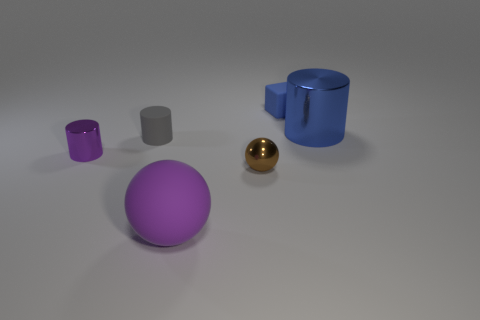The tiny matte cube has what color?
Keep it short and to the point. Blue. How many objects are large blue cylinders or large gray matte cylinders?
Your answer should be very brief. 1. There is a matte object that is behind the large object that is behind the purple rubber object; what is its shape?
Make the answer very short. Cube. How many other objects are the same material as the gray object?
Make the answer very short. 2. Are the blue block and the large thing that is on the right side of the block made of the same material?
Your answer should be compact. No. What number of objects are either shiny cylinders on the right side of the large matte thing or tiny objects in front of the tiny purple cylinder?
Offer a very short reply. 2. How many other objects are there of the same color as the large matte object?
Keep it short and to the point. 1. Is the number of gray things in front of the gray cylinder greater than the number of brown metallic objects that are behind the purple cylinder?
Provide a short and direct response. No. Is there anything else that has the same size as the purple matte thing?
Offer a very short reply. Yes. How many cylinders are large red rubber things or blue rubber things?
Offer a very short reply. 0. 